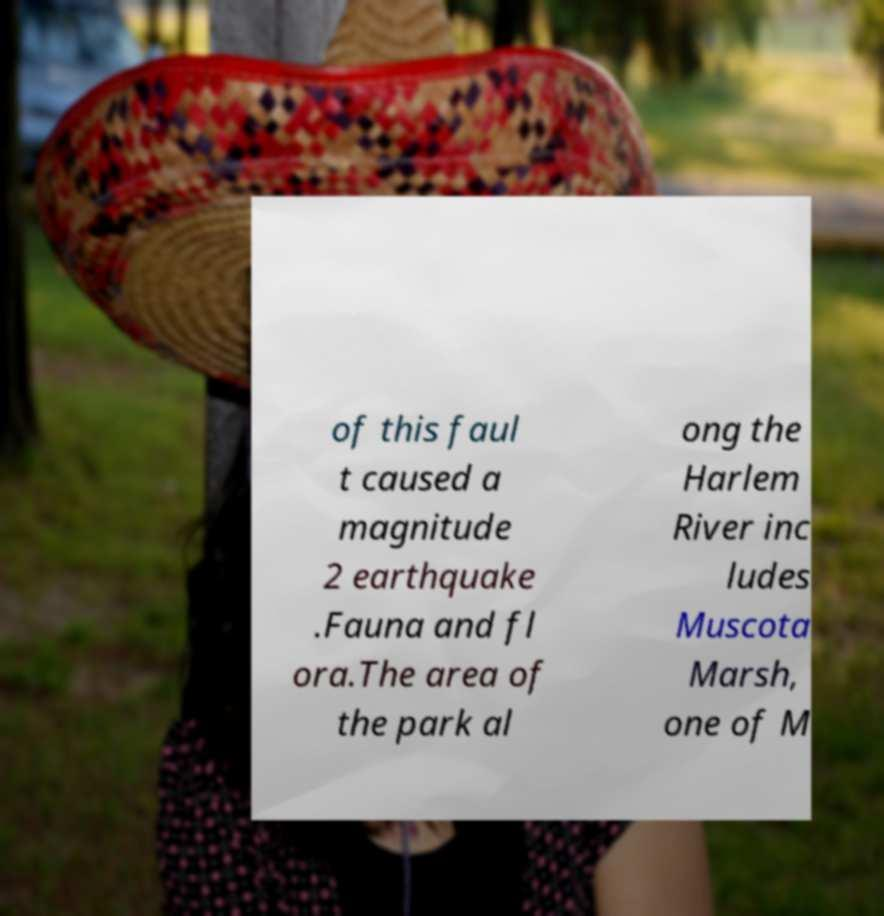Can you accurately transcribe the text from the provided image for me? of this faul t caused a magnitude 2 earthquake .Fauna and fl ora.The area of the park al ong the Harlem River inc ludes Muscota Marsh, one of M 